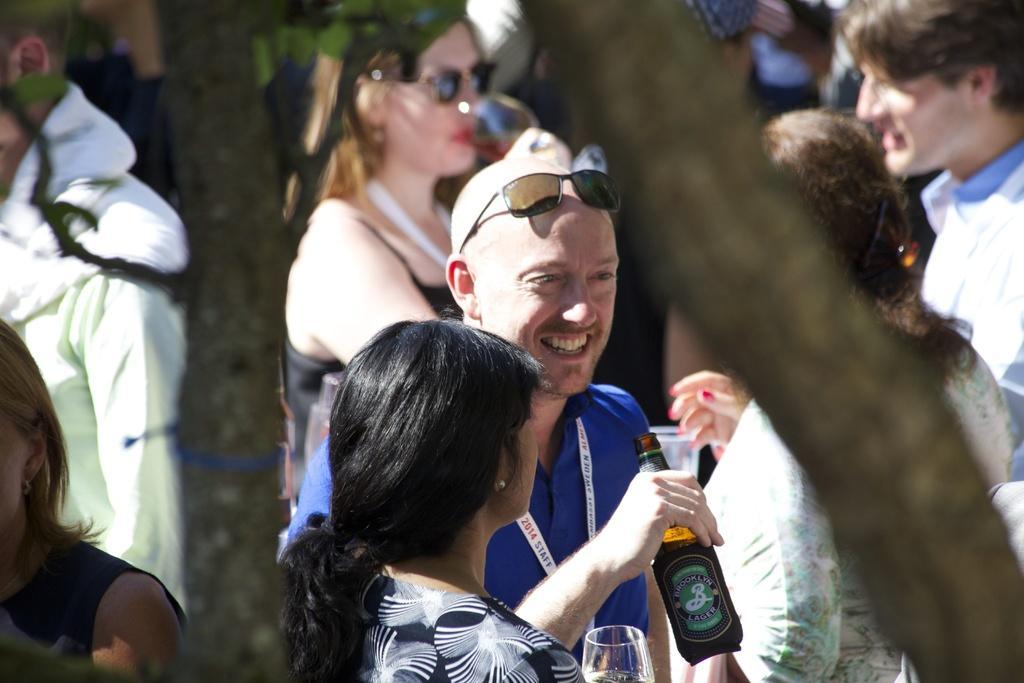How would you summarize this image in a sentence or two? In this image, there are group of people standing and talking and holding a wine bottle in their hands. On both side left and right, tree trunk is visible. This image is taken during a sunny day. 